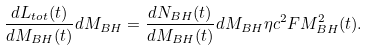<formula> <loc_0><loc_0><loc_500><loc_500>\frac { d L _ { t o t } ( t ) } { d M _ { B H } ( t ) } d M _ { B H } = \frac { d N _ { B H } ( t ) } { d M _ { B H } ( t ) } d M _ { B H } \eta c ^ { 2 } F M _ { B H } ^ { 2 } ( t ) .</formula> 